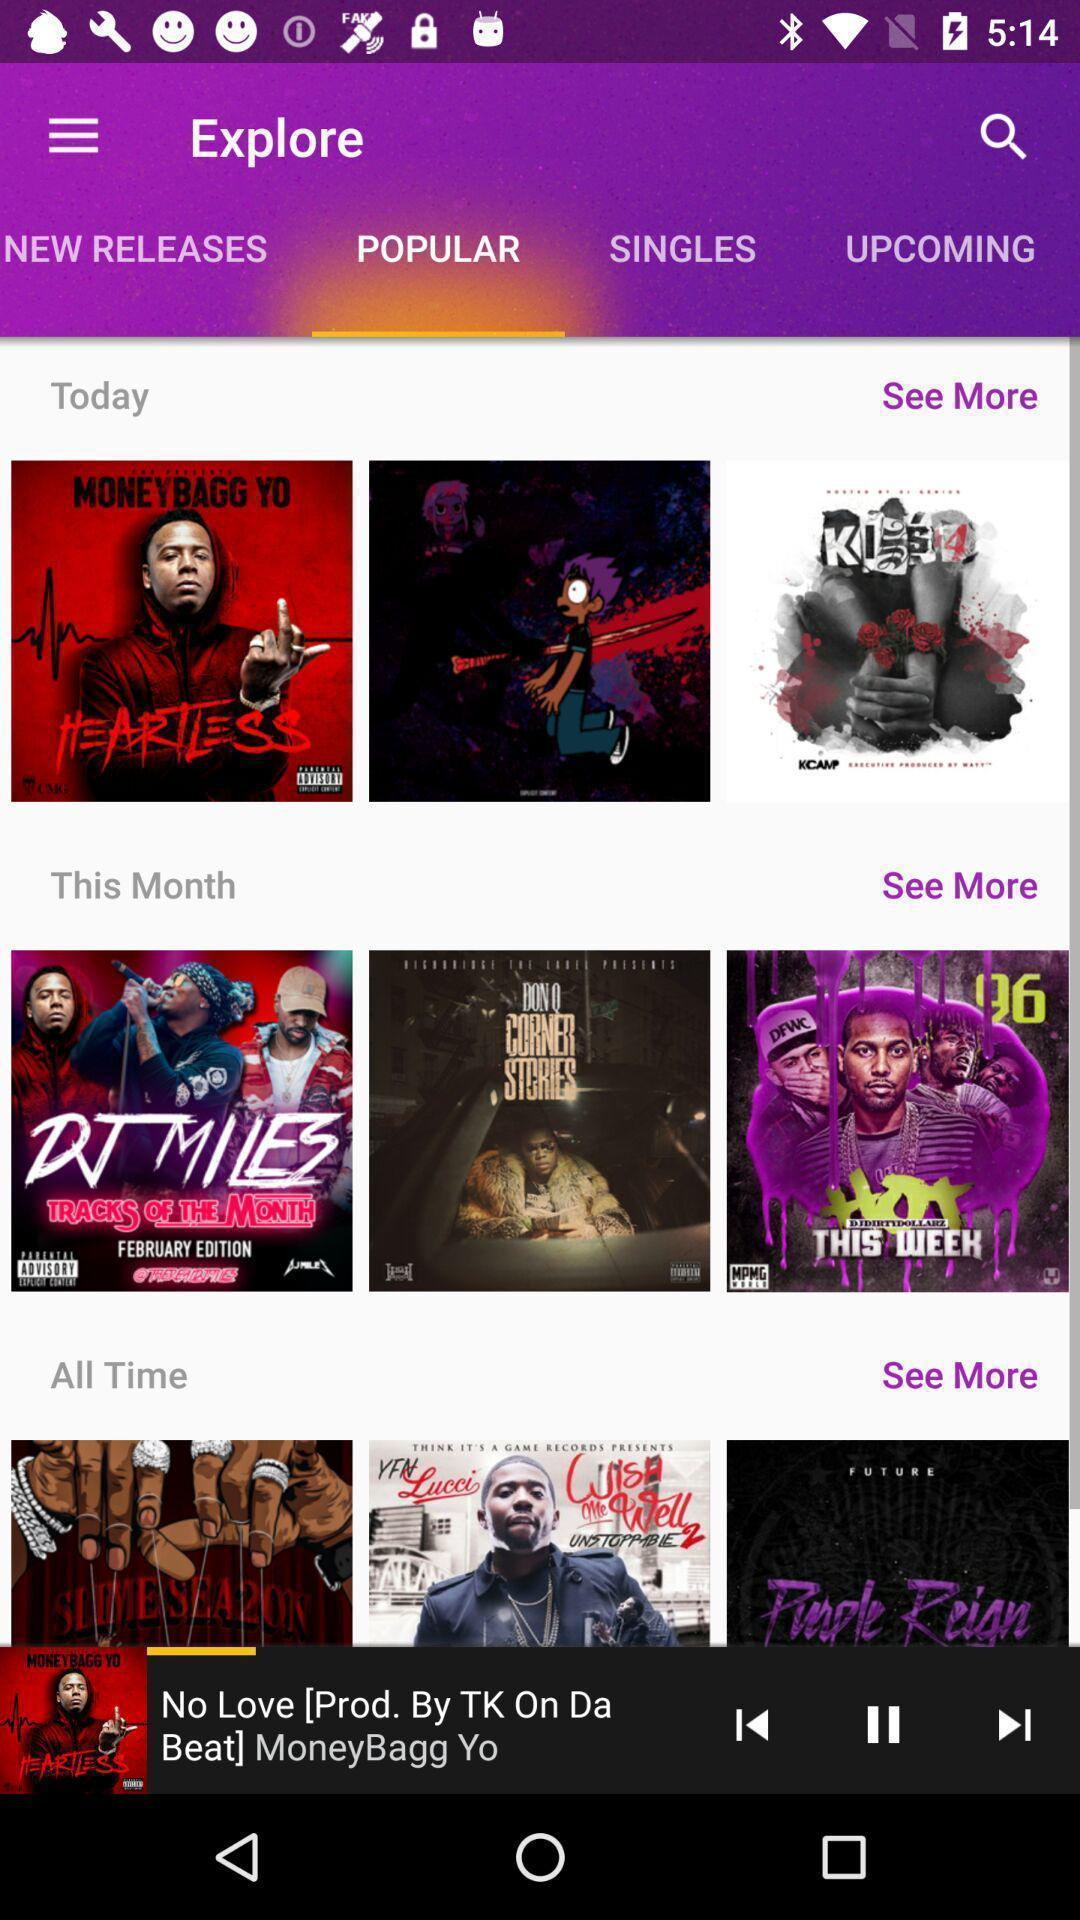Describe the key features of this screenshot. Screen showing popular mixtapes in an music application. 